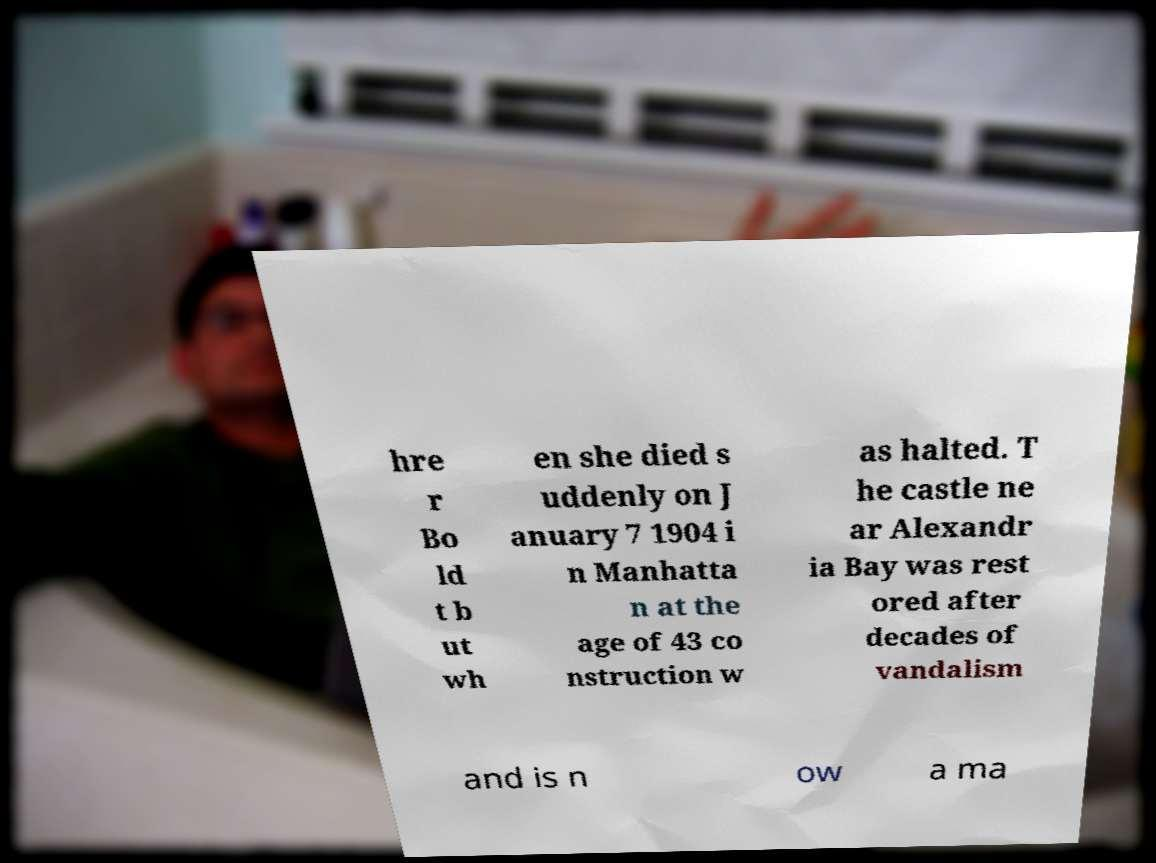Could you assist in decoding the text presented in this image and type it out clearly? hre r Bo ld t b ut wh en she died s uddenly on J anuary 7 1904 i n Manhatta n at the age of 43 co nstruction w as halted. T he castle ne ar Alexandr ia Bay was rest ored after decades of vandalism and is n ow a ma 